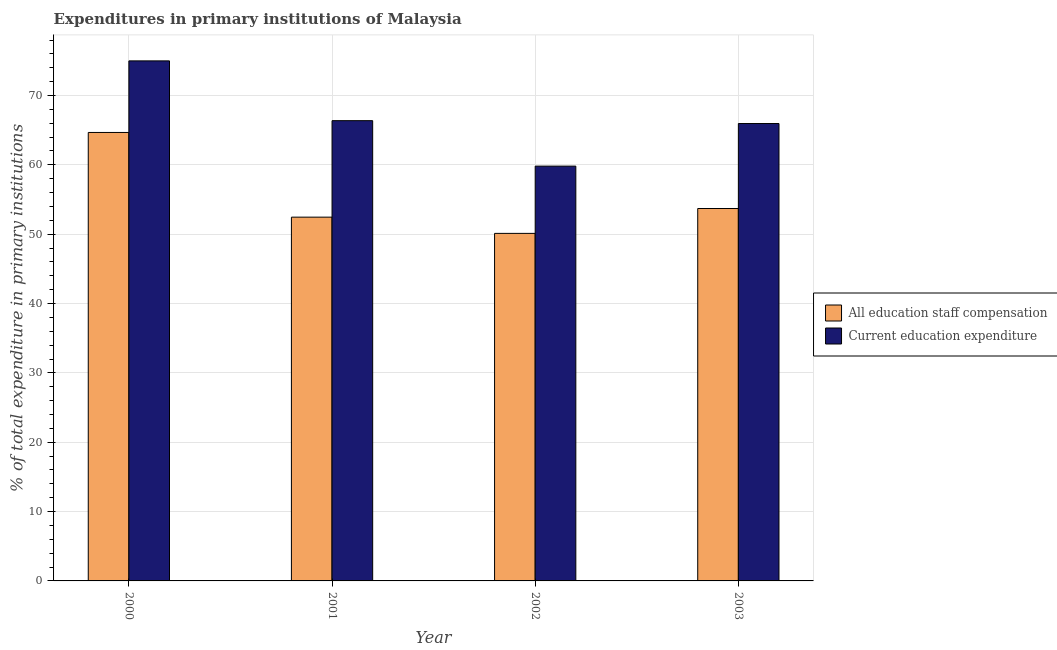How many different coloured bars are there?
Offer a very short reply. 2. Are the number of bars per tick equal to the number of legend labels?
Your answer should be very brief. Yes. In how many cases, is the number of bars for a given year not equal to the number of legend labels?
Keep it short and to the point. 0. What is the expenditure in staff compensation in 2002?
Provide a short and direct response. 50.12. Across all years, what is the maximum expenditure in staff compensation?
Ensure brevity in your answer.  64.67. Across all years, what is the minimum expenditure in education?
Make the answer very short. 59.82. In which year was the expenditure in education maximum?
Your response must be concise. 2000. What is the total expenditure in staff compensation in the graph?
Provide a short and direct response. 220.96. What is the difference between the expenditure in education in 2002 and that in 2003?
Your response must be concise. -6.14. What is the difference between the expenditure in education in 2000 and the expenditure in staff compensation in 2002?
Offer a very short reply. 15.18. What is the average expenditure in education per year?
Provide a succinct answer. 66.79. In how many years, is the expenditure in staff compensation greater than 28 %?
Keep it short and to the point. 4. What is the ratio of the expenditure in education in 2001 to that in 2003?
Your response must be concise. 1.01. Is the expenditure in education in 2000 less than that in 2002?
Make the answer very short. No. What is the difference between the highest and the second highest expenditure in staff compensation?
Provide a short and direct response. 10.97. What is the difference between the highest and the lowest expenditure in staff compensation?
Your answer should be very brief. 14.55. What does the 1st bar from the left in 2001 represents?
Make the answer very short. All education staff compensation. What does the 2nd bar from the right in 2002 represents?
Keep it short and to the point. All education staff compensation. How many bars are there?
Ensure brevity in your answer.  8. Are all the bars in the graph horizontal?
Give a very brief answer. No. What is the difference between two consecutive major ticks on the Y-axis?
Provide a succinct answer. 10. Does the graph contain any zero values?
Your answer should be very brief. No. Does the graph contain grids?
Ensure brevity in your answer.  Yes. Where does the legend appear in the graph?
Ensure brevity in your answer.  Center right. What is the title of the graph?
Ensure brevity in your answer.  Expenditures in primary institutions of Malaysia. Does "Register a property" appear as one of the legend labels in the graph?
Give a very brief answer. No. What is the label or title of the Y-axis?
Your answer should be very brief. % of total expenditure in primary institutions. What is the % of total expenditure in primary institutions in All education staff compensation in 2000?
Your answer should be compact. 64.67. What is the % of total expenditure in primary institutions in Current education expenditure in 2000?
Your answer should be compact. 75. What is the % of total expenditure in primary institutions in All education staff compensation in 2001?
Provide a succinct answer. 52.46. What is the % of total expenditure in primary institutions of Current education expenditure in 2001?
Your answer should be compact. 66.37. What is the % of total expenditure in primary institutions of All education staff compensation in 2002?
Provide a short and direct response. 50.12. What is the % of total expenditure in primary institutions of Current education expenditure in 2002?
Offer a terse response. 59.82. What is the % of total expenditure in primary institutions of All education staff compensation in 2003?
Provide a short and direct response. 53.71. What is the % of total expenditure in primary institutions of Current education expenditure in 2003?
Offer a terse response. 65.96. Across all years, what is the maximum % of total expenditure in primary institutions of All education staff compensation?
Your answer should be very brief. 64.67. Across all years, what is the maximum % of total expenditure in primary institutions in Current education expenditure?
Offer a very short reply. 75. Across all years, what is the minimum % of total expenditure in primary institutions in All education staff compensation?
Keep it short and to the point. 50.12. Across all years, what is the minimum % of total expenditure in primary institutions of Current education expenditure?
Your answer should be very brief. 59.82. What is the total % of total expenditure in primary institutions in All education staff compensation in the graph?
Give a very brief answer. 220.96. What is the total % of total expenditure in primary institutions of Current education expenditure in the graph?
Give a very brief answer. 267.15. What is the difference between the % of total expenditure in primary institutions of All education staff compensation in 2000 and that in 2001?
Keep it short and to the point. 12.21. What is the difference between the % of total expenditure in primary institutions of Current education expenditure in 2000 and that in 2001?
Your answer should be very brief. 8.62. What is the difference between the % of total expenditure in primary institutions in All education staff compensation in 2000 and that in 2002?
Keep it short and to the point. 14.55. What is the difference between the % of total expenditure in primary institutions in Current education expenditure in 2000 and that in 2002?
Keep it short and to the point. 15.18. What is the difference between the % of total expenditure in primary institutions of All education staff compensation in 2000 and that in 2003?
Ensure brevity in your answer.  10.97. What is the difference between the % of total expenditure in primary institutions of Current education expenditure in 2000 and that in 2003?
Provide a succinct answer. 9.03. What is the difference between the % of total expenditure in primary institutions of All education staff compensation in 2001 and that in 2002?
Provide a short and direct response. 2.34. What is the difference between the % of total expenditure in primary institutions of Current education expenditure in 2001 and that in 2002?
Offer a terse response. 6.55. What is the difference between the % of total expenditure in primary institutions in All education staff compensation in 2001 and that in 2003?
Make the answer very short. -1.25. What is the difference between the % of total expenditure in primary institutions in Current education expenditure in 2001 and that in 2003?
Ensure brevity in your answer.  0.41. What is the difference between the % of total expenditure in primary institutions of All education staff compensation in 2002 and that in 2003?
Keep it short and to the point. -3.59. What is the difference between the % of total expenditure in primary institutions of Current education expenditure in 2002 and that in 2003?
Offer a terse response. -6.14. What is the difference between the % of total expenditure in primary institutions in All education staff compensation in 2000 and the % of total expenditure in primary institutions in Current education expenditure in 2001?
Provide a succinct answer. -1.7. What is the difference between the % of total expenditure in primary institutions in All education staff compensation in 2000 and the % of total expenditure in primary institutions in Current education expenditure in 2002?
Ensure brevity in your answer.  4.85. What is the difference between the % of total expenditure in primary institutions in All education staff compensation in 2000 and the % of total expenditure in primary institutions in Current education expenditure in 2003?
Ensure brevity in your answer.  -1.29. What is the difference between the % of total expenditure in primary institutions in All education staff compensation in 2001 and the % of total expenditure in primary institutions in Current education expenditure in 2002?
Provide a short and direct response. -7.36. What is the difference between the % of total expenditure in primary institutions of All education staff compensation in 2001 and the % of total expenditure in primary institutions of Current education expenditure in 2003?
Give a very brief answer. -13.5. What is the difference between the % of total expenditure in primary institutions in All education staff compensation in 2002 and the % of total expenditure in primary institutions in Current education expenditure in 2003?
Keep it short and to the point. -15.84. What is the average % of total expenditure in primary institutions of All education staff compensation per year?
Provide a succinct answer. 55.24. What is the average % of total expenditure in primary institutions of Current education expenditure per year?
Provide a succinct answer. 66.79. In the year 2000, what is the difference between the % of total expenditure in primary institutions in All education staff compensation and % of total expenditure in primary institutions in Current education expenditure?
Give a very brief answer. -10.32. In the year 2001, what is the difference between the % of total expenditure in primary institutions in All education staff compensation and % of total expenditure in primary institutions in Current education expenditure?
Make the answer very short. -13.91. In the year 2002, what is the difference between the % of total expenditure in primary institutions in All education staff compensation and % of total expenditure in primary institutions in Current education expenditure?
Provide a succinct answer. -9.7. In the year 2003, what is the difference between the % of total expenditure in primary institutions of All education staff compensation and % of total expenditure in primary institutions of Current education expenditure?
Offer a terse response. -12.26. What is the ratio of the % of total expenditure in primary institutions in All education staff compensation in 2000 to that in 2001?
Provide a succinct answer. 1.23. What is the ratio of the % of total expenditure in primary institutions in Current education expenditure in 2000 to that in 2001?
Ensure brevity in your answer.  1.13. What is the ratio of the % of total expenditure in primary institutions in All education staff compensation in 2000 to that in 2002?
Offer a very short reply. 1.29. What is the ratio of the % of total expenditure in primary institutions in Current education expenditure in 2000 to that in 2002?
Make the answer very short. 1.25. What is the ratio of the % of total expenditure in primary institutions in All education staff compensation in 2000 to that in 2003?
Make the answer very short. 1.2. What is the ratio of the % of total expenditure in primary institutions of Current education expenditure in 2000 to that in 2003?
Make the answer very short. 1.14. What is the ratio of the % of total expenditure in primary institutions in All education staff compensation in 2001 to that in 2002?
Make the answer very short. 1.05. What is the ratio of the % of total expenditure in primary institutions of Current education expenditure in 2001 to that in 2002?
Provide a succinct answer. 1.11. What is the ratio of the % of total expenditure in primary institutions of All education staff compensation in 2001 to that in 2003?
Your answer should be compact. 0.98. What is the ratio of the % of total expenditure in primary institutions in Current education expenditure in 2001 to that in 2003?
Offer a terse response. 1.01. What is the ratio of the % of total expenditure in primary institutions in All education staff compensation in 2002 to that in 2003?
Your response must be concise. 0.93. What is the ratio of the % of total expenditure in primary institutions in Current education expenditure in 2002 to that in 2003?
Provide a succinct answer. 0.91. What is the difference between the highest and the second highest % of total expenditure in primary institutions of All education staff compensation?
Your answer should be very brief. 10.97. What is the difference between the highest and the second highest % of total expenditure in primary institutions of Current education expenditure?
Your answer should be very brief. 8.62. What is the difference between the highest and the lowest % of total expenditure in primary institutions in All education staff compensation?
Give a very brief answer. 14.55. What is the difference between the highest and the lowest % of total expenditure in primary institutions in Current education expenditure?
Offer a terse response. 15.18. 